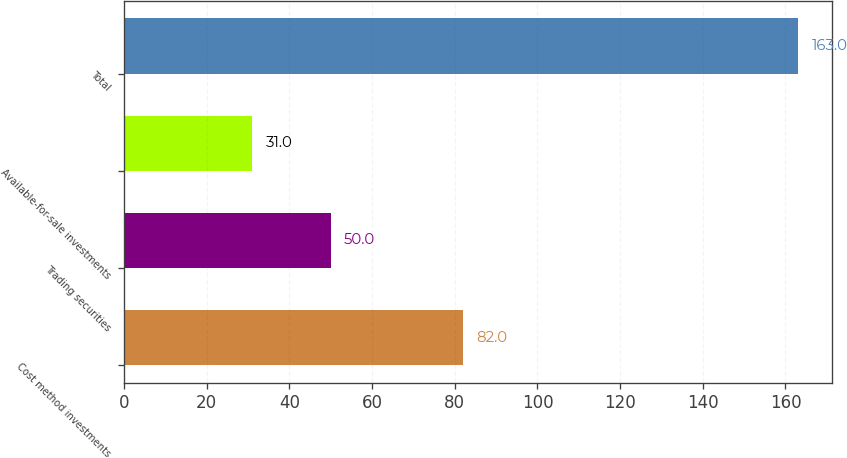Convert chart. <chart><loc_0><loc_0><loc_500><loc_500><bar_chart><fcel>Cost method investments<fcel>Trading securities<fcel>Available-for-sale investments<fcel>Total<nl><fcel>82<fcel>50<fcel>31<fcel>163<nl></chart> 